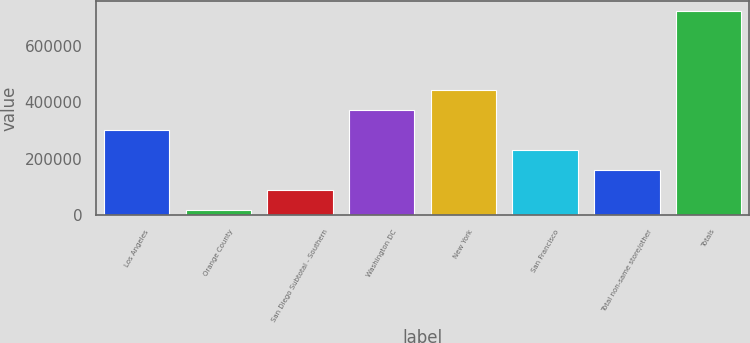Convert chart to OTSL. <chart><loc_0><loc_0><loc_500><loc_500><bar_chart><fcel>Los Angeles<fcel>Orange County<fcel>San Diego Subtotal - Southern<fcel>Washington DC<fcel>New York<fcel>San Francisco<fcel>Total non-same store/other<fcel>Totals<nl><fcel>302044<fcel>20600<fcel>90961<fcel>372405<fcel>442766<fcel>231683<fcel>161322<fcel>724210<nl></chart> 